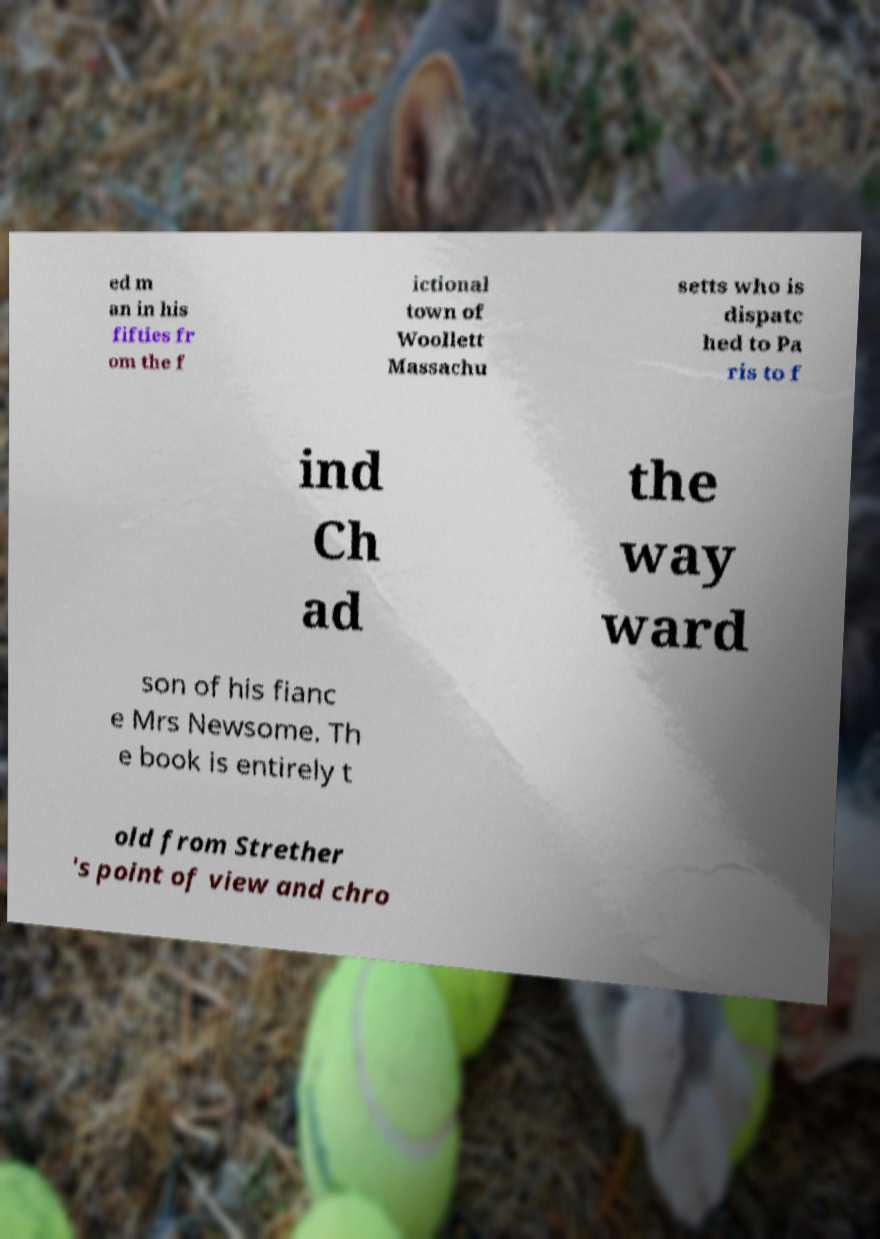Could you extract and type out the text from this image? ed m an in his fifties fr om the f ictional town of Woollett Massachu setts who is dispatc hed to Pa ris to f ind Ch ad the way ward son of his fianc e Mrs Newsome. Th e book is entirely t old from Strether 's point of view and chro 